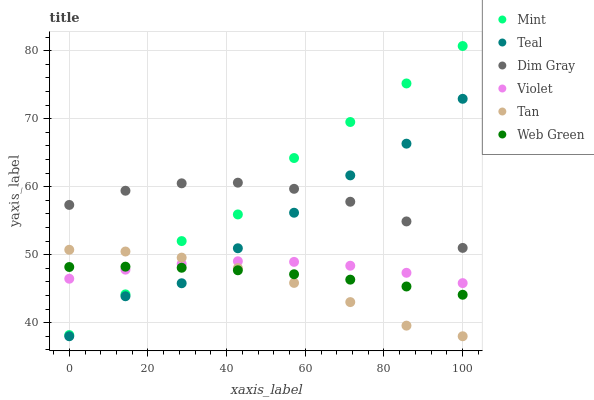Does Tan have the minimum area under the curve?
Answer yes or no. Yes. Does Mint have the maximum area under the curve?
Answer yes or no. Yes. Does Web Green have the minimum area under the curve?
Answer yes or no. No. Does Web Green have the maximum area under the curve?
Answer yes or no. No. Is Web Green the smoothest?
Answer yes or no. Yes. Is Mint the roughest?
Answer yes or no. Yes. Is Teal the smoothest?
Answer yes or no. No. Is Teal the roughest?
Answer yes or no. No. Does Teal have the lowest value?
Answer yes or no. Yes. Does Web Green have the lowest value?
Answer yes or no. No. Does Mint have the highest value?
Answer yes or no. Yes. Does Teal have the highest value?
Answer yes or no. No. Is Web Green less than Dim Gray?
Answer yes or no. Yes. Is Dim Gray greater than Violet?
Answer yes or no. Yes. Does Teal intersect Dim Gray?
Answer yes or no. Yes. Is Teal less than Dim Gray?
Answer yes or no. No. Is Teal greater than Dim Gray?
Answer yes or no. No. Does Web Green intersect Dim Gray?
Answer yes or no. No. 